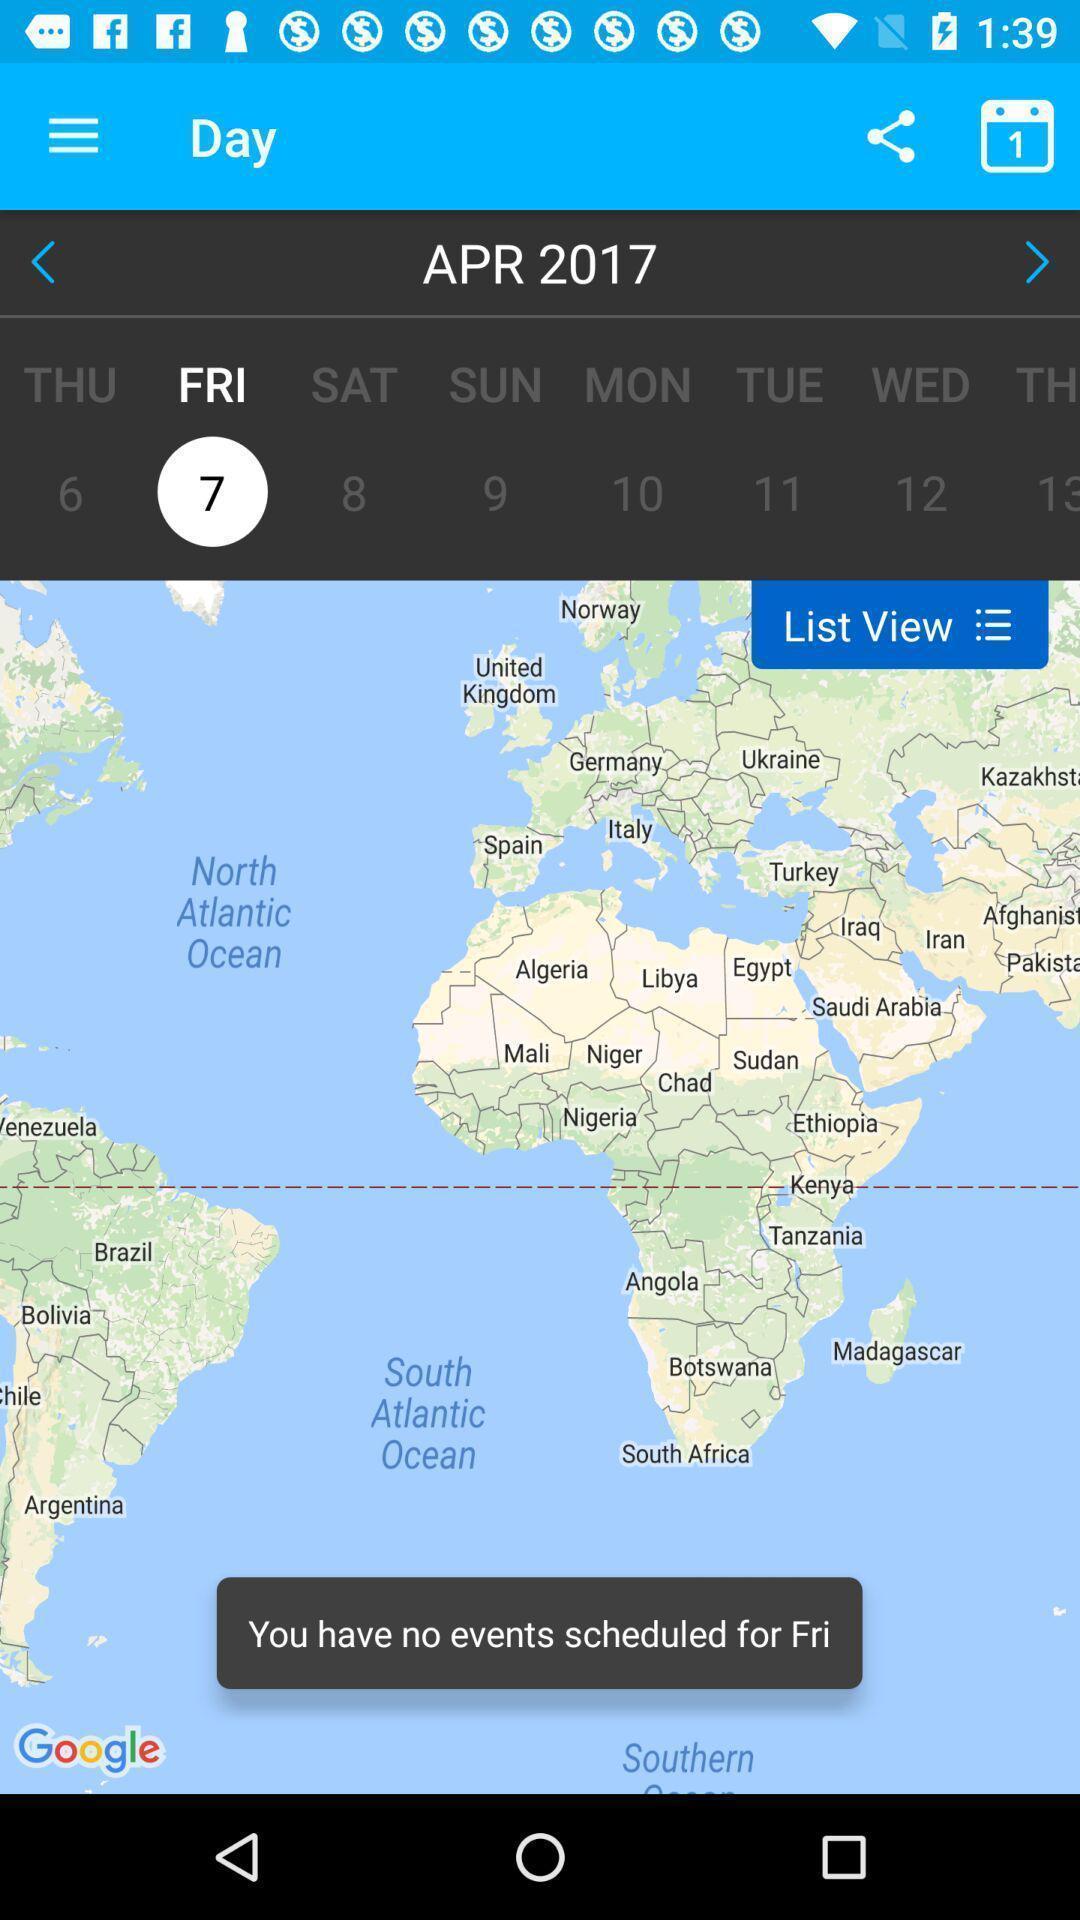Explain the elements present in this screenshot. Page shows day reminders in the schedule planning app. 